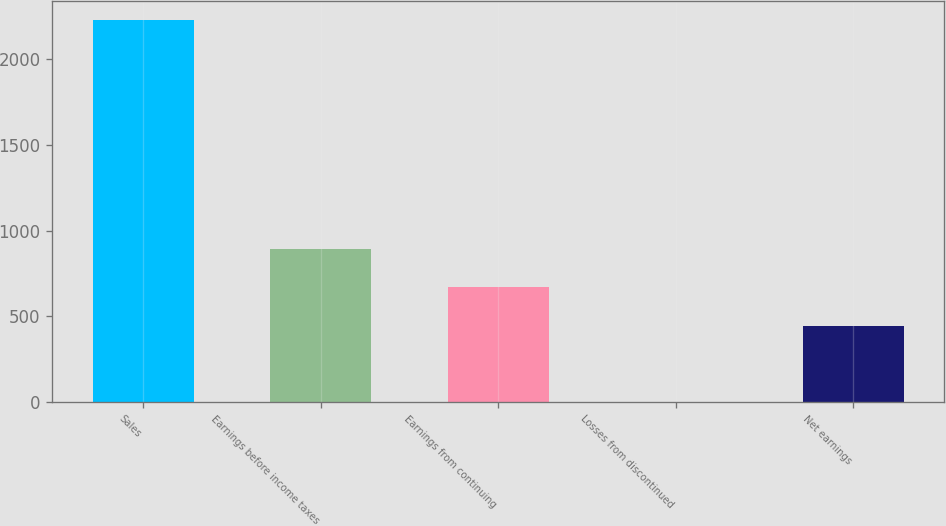<chart> <loc_0><loc_0><loc_500><loc_500><bar_chart><fcel>Sales<fcel>Earnings before income taxes<fcel>Earnings from continuing<fcel>Losses from discontinued<fcel>Net earnings<nl><fcel>2229.1<fcel>891.65<fcel>668.74<fcel>0.01<fcel>445.83<nl></chart> 